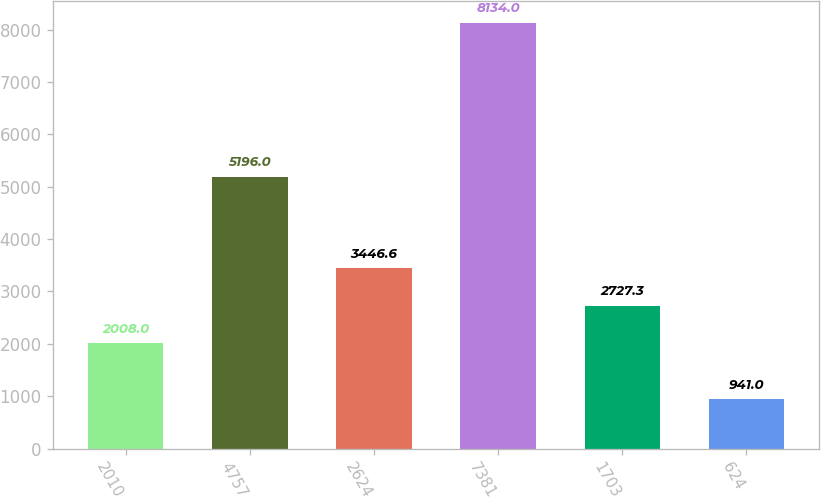<chart> <loc_0><loc_0><loc_500><loc_500><bar_chart><fcel>2010<fcel>4757<fcel>2624<fcel>7381<fcel>1703<fcel>624<nl><fcel>2008<fcel>5196<fcel>3446.6<fcel>8134<fcel>2727.3<fcel>941<nl></chart> 